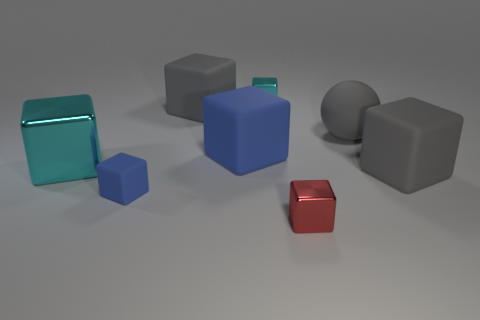Subtract 1 cubes. How many cubes are left? 6 Subtract all gray cubes. How many cubes are left? 5 Subtract all large blocks. How many blocks are left? 3 Subtract all gray cubes. Subtract all yellow cylinders. How many cubes are left? 5 Add 1 big blue blocks. How many objects exist? 9 Subtract all blocks. How many objects are left? 1 Add 8 gray metal things. How many gray metal things exist? 8 Subtract 0 gray cylinders. How many objects are left? 8 Subtract all small gray matte cylinders. Subtract all red things. How many objects are left? 7 Add 6 gray matte objects. How many gray matte objects are left? 9 